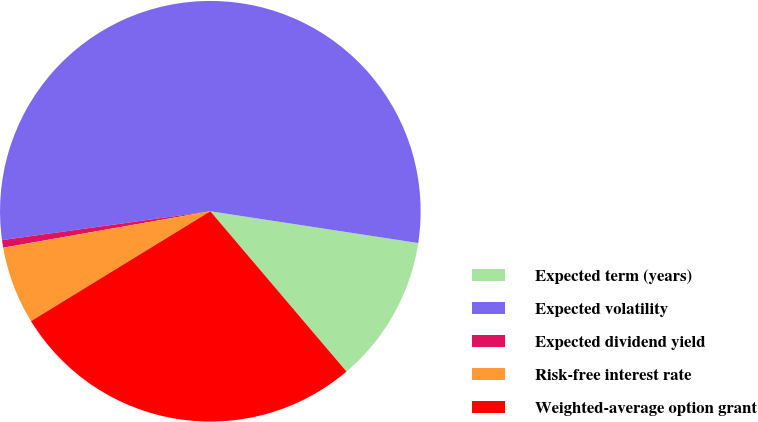<chart> <loc_0><loc_0><loc_500><loc_500><pie_chart><fcel>Expected term (years)<fcel>Expected volatility<fcel>Expected dividend yield<fcel>Risk-free interest rate<fcel>Weighted-average option grant<nl><fcel>11.38%<fcel>54.61%<fcel>0.58%<fcel>5.98%<fcel>27.46%<nl></chart> 